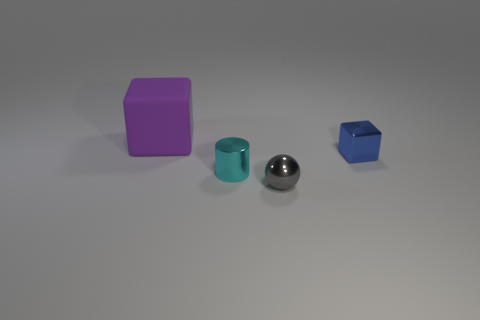Add 1 small gray metal balls. How many objects exist? 5 Subtract all balls. How many objects are left? 3 Subtract all blue shiny things. Subtract all tiny objects. How many objects are left? 0 Add 3 blue metal objects. How many blue metal objects are left? 4 Add 4 big purple rubber cubes. How many big purple rubber cubes exist? 5 Subtract 0 yellow spheres. How many objects are left? 4 